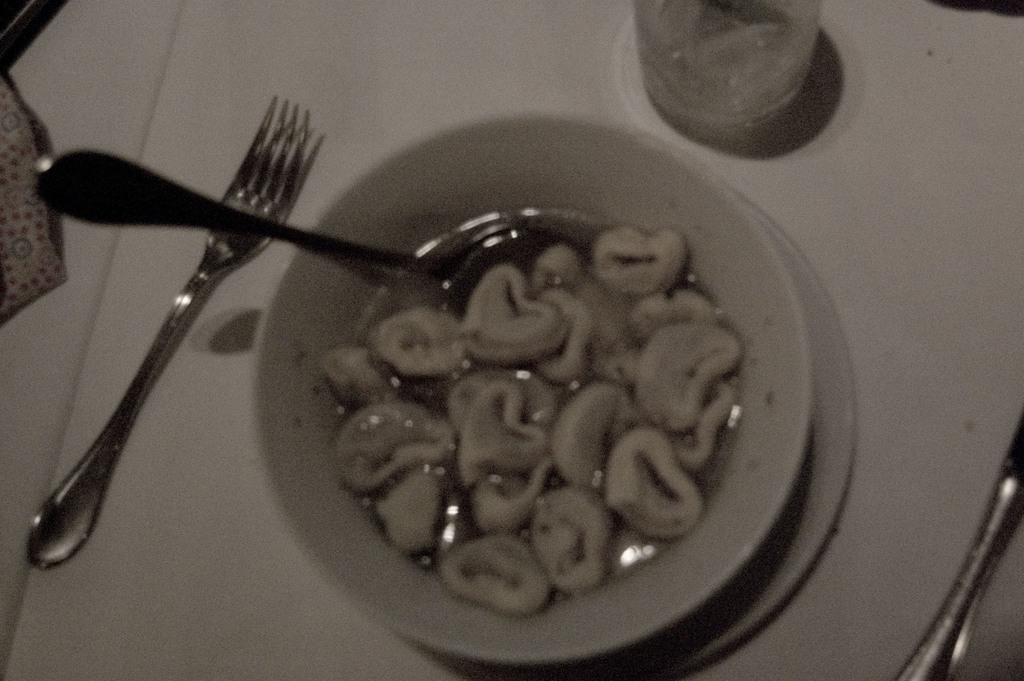What utensil is visible in the image? There is a spoon in the image. What is contained in the bowl in the image? There is food in a bowl in the image. What is located beside the bowl in the image? There is a glass beside the bowl in the image. What other utensil is present in the image? There is a fork in the image. Can you describe any other items in the image? There are other unspecified things in the image. What time is displayed on the clock in the image? There is no clock present in the image. How many cattle are visible in the image? There are no cattle present in the image. 